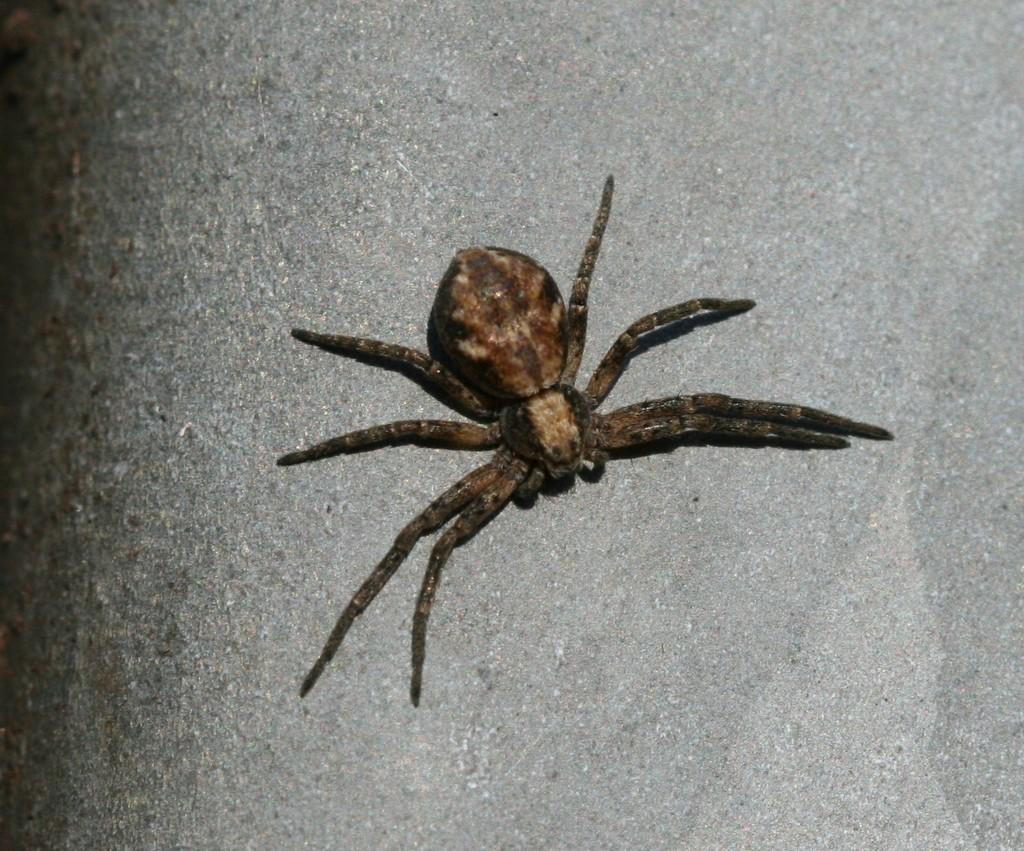What is the main subject of the image? The main subject of the image is a spider. Where is the spider located in the image? The spider is on a platform in the image. Can you tell me how the spider is helping the friend cross the stream in the image? There is no stream or friend present in the image; it only features a spider on a platform. 